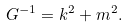<formula> <loc_0><loc_0><loc_500><loc_500>G ^ { - 1 } = k ^ { 2 } + m ^ { 2 } .</formula> 